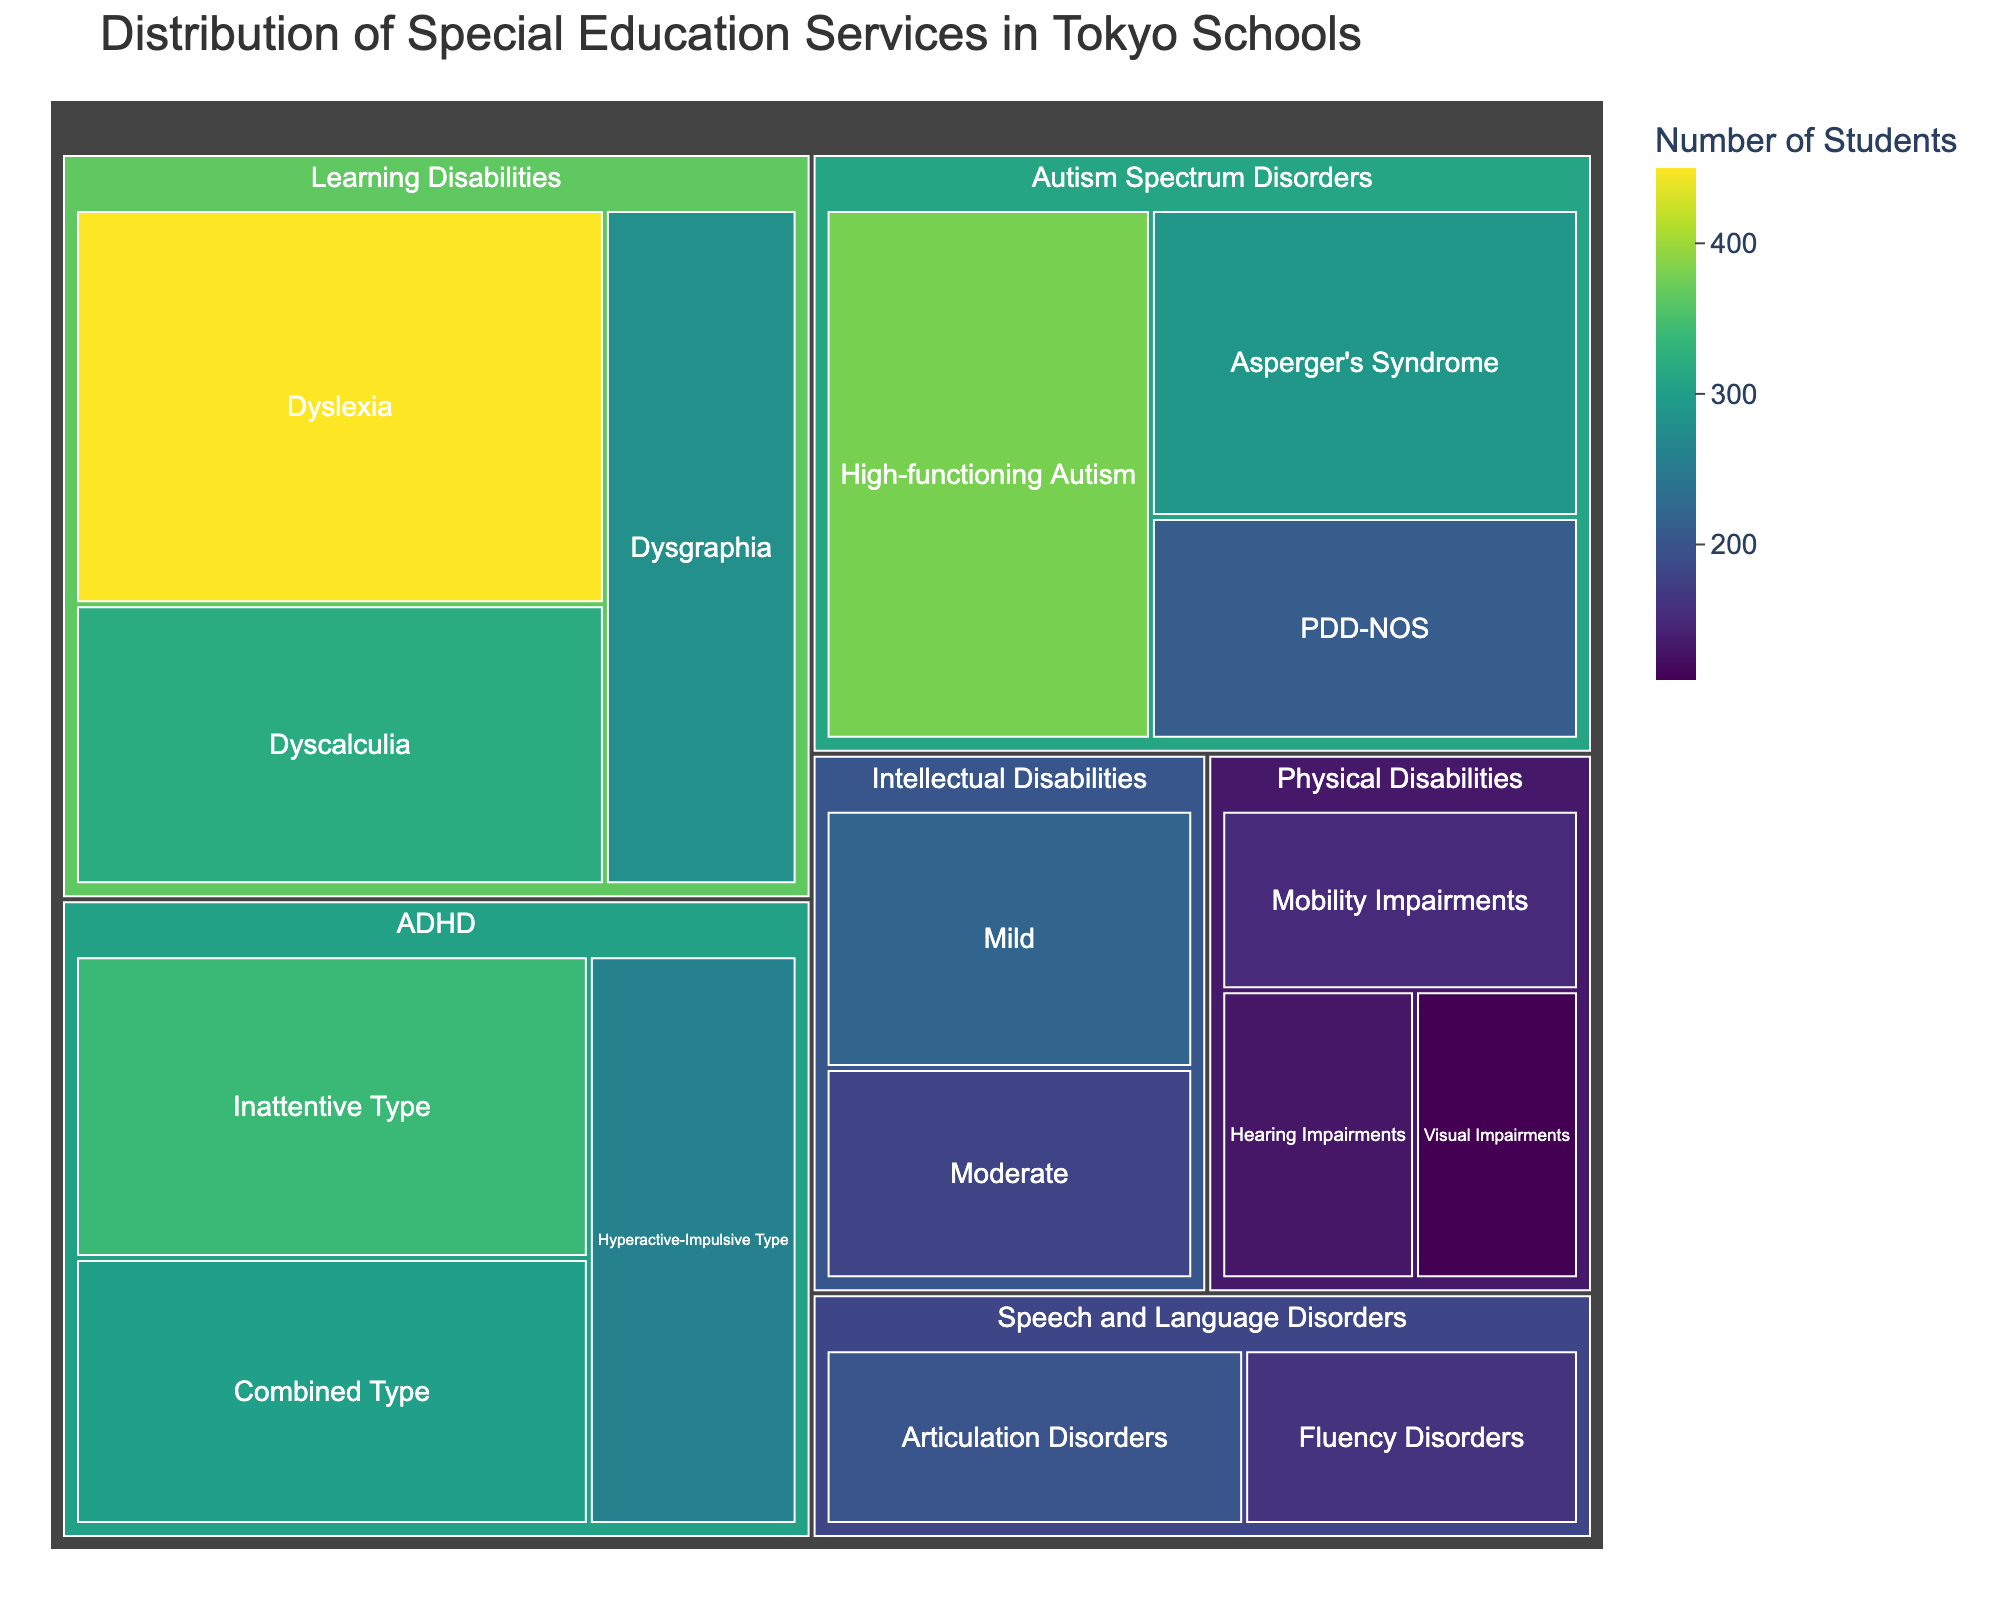What is the total number of students receiving Dyslexia support? Look for the section or tile labeled "Dyslexia" in the "Learning Disabilities" category in the treemap. The number of students in that section is shown to be 450.
Answer: 450 What is the total number of students receiving support in the Learning Disabilities category? Sum the number of students from each type of learning disability: Dyslexia (450) + Dyscalculia (320) + Dysgraphia (280). The total is 450 + 320 + 280 = 1050.
Answer: 1050 Which category has the smallest number of students receiving support, and what is the number? Compare the numbers from each main category. Physical Disabilities has the smallest numbers: Mobility Impairments (150), Visual Impairments (110), Hearing Impairments (130), which sums up to 150 + 110 + 130 = 390.
Answer: Physical Disabilities, 390 How many more students receive High-functioning Autism support compared to Asperger's Syndrome? Subtract the number of students with Asperger's Syndrome (290) from the number of students with High-functioning Autism (380). The difference is 380 - 290 = 90.
Answer: 90 What type of Speech and Language Disorder has fewer students, and by how many? Compare the number of students with Articulation Disorders (200) and Fluency Disorders (160). Subtract the smaller from the larger: 200 - 160 = 40.
Answer: Fluency Disorders, 40 Which type of ADHD has the highest number of students, and what is that number? Compare the number of students for each ADHD type: Inattentive Type (340), Hyperactive-Impulsive Type (260), Combined Type (300). The highest is Inattentive Type with 340 students.
Answer: Inattentive Type, 340 What is the average number of students receiving support across all types of Intellectual Disabilities? Add the number of students in each type of Intellectual Disability (Mild: 220, Moderate: 180), then divide by the number of types (2). (220 + 180) / 2 = 200.
Answer: 200 What is the largest group of students within the Autism Spectrum Disorders category? Look within the Autism Spectrum Disorders category and find the largest number: High-functioning Autism (380).
Answer: High-functioning Autism Between Physical Disabilities and Speech and Language Disorders, which category supports more students? Sum the number of students in each category. Physical Disabilities: 150+110+130=390; Speech and Language Disorders: 200+160=360. Compare the sums, 390 > 360.
Answer: Physical Disabilities What is the combined number of students receiving support for all types of special education services in Tokyo schools? Add the number of students in each category and type: 450+320+280+380+290+210+340+260+300+220+180+150+110+130+200+160 = 3980.
Answer: 3980 